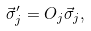Convert formula to latex. <formula><loc_0><loc_0><loc_500><loc_500>\vec { \sigma } ^ { \prime } _ { j } = O _ { j } \vec { \sigma } _ { j } ,</formula> 